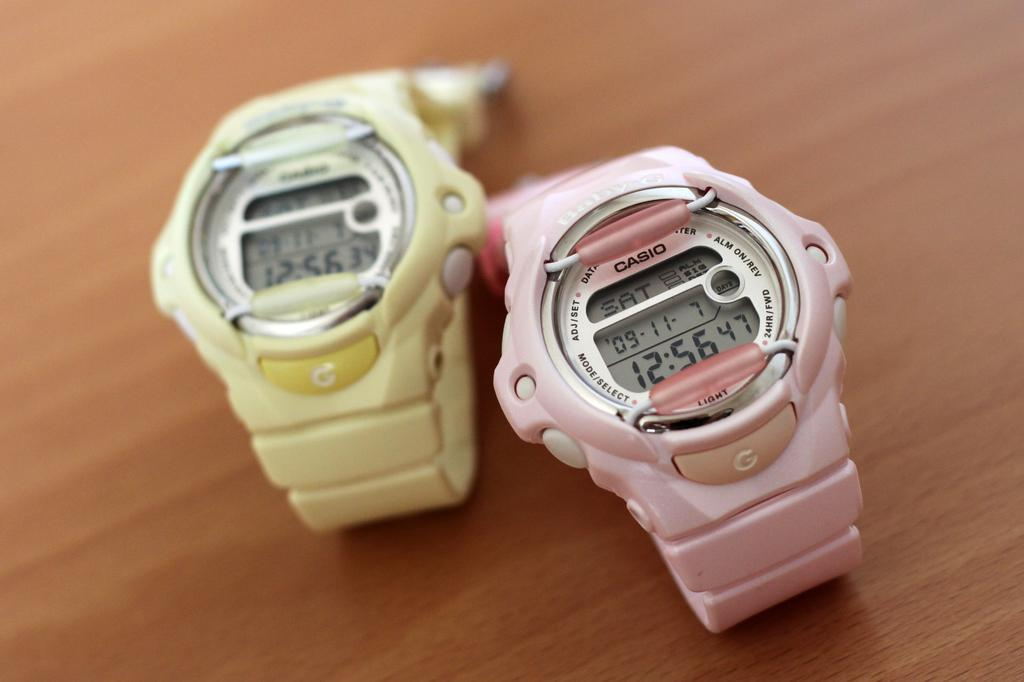<image>
Present a compact description of the photo's key features. A yellow and a pink digital watch showing time at 12:56, Saturday, on September 11. 